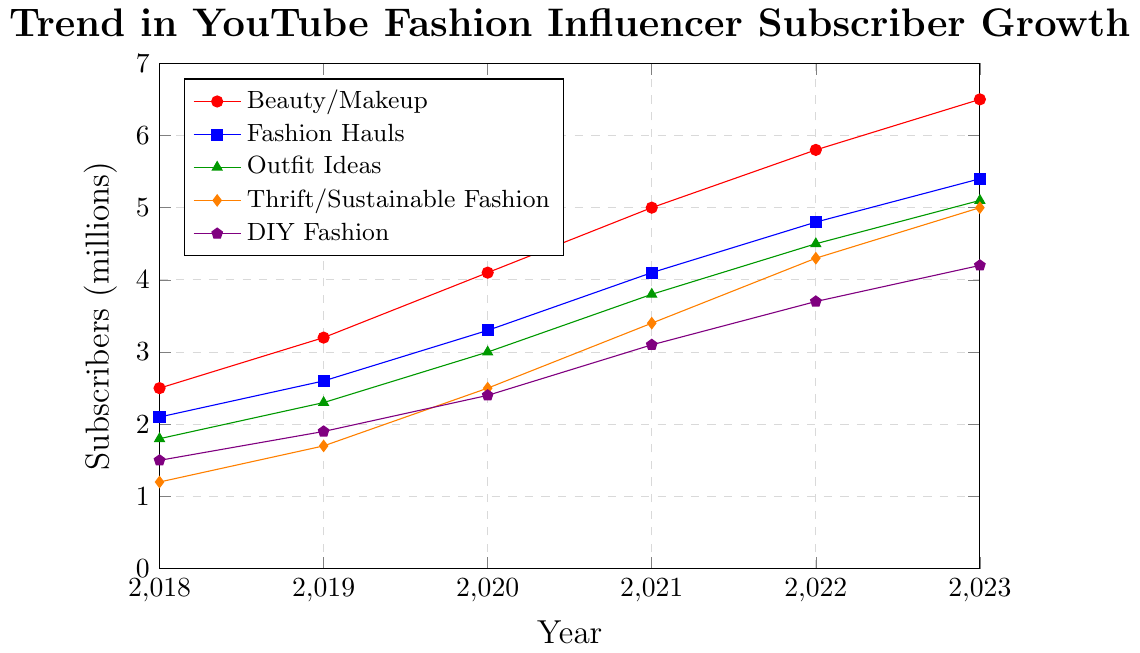What is the trend in subscriber growth for Beauty/Makeup content from 2018 to 2023? The chart shows that the subscriber count for Beauty/Makeup content increased each year from 2.5 million in 2018 to 6.5 million in 2023.
Answer: Consistent increase Which content type had the highest subscriber growth in 2023? By inspecting the chart for the year 2023, Beauty/Makeup reached 6.5 million subscribers, which is the highest among all content types.
Answer: Beauty/Makeup How much did the subscriber count for Thrift/Sustainable Fashion content increase from 2018 to 2023? The Thrift/Sustainable Fashion content rose from 1.2 million subscribers in 2018 to 5.0 million in 2023. The increase is calculated as 5.0 - 1.2 = 3.8 million.
Answer: 3.8 million Was the growth in Fashion Hauls subscribers greater between 2019 and 2020 or between 2022 and 2023? Between 2019 and 2020, the growth for Fashion Hauls is 3.3 - 2.6 = 0.7 million. Between 2022 and 2023, the increase is 5.4 - 4.8 = 0.6 million. Thus, the growth from 2019 to 2020 was greater.
Answer: 2019 to 2020 Which content type had the least growth overall from 2018 to 2023? By comparing the subscriber counts from 2018 to 2023, DIY Fashion increased from 1.5 to 4.2 million, the least among all content types.
Answer: DIY Fashion What was the average number of subscribers for Outfit Ideas in the given period? First, sum the subscriber counts for Outfit Ideas: 1.8 + 2.3 + 3.0 + 3.8 + 4.5 + 5.1 = 20.5 million. There are 6 years, so the average is 20.5 / 6 = 3.417 million.
Answer: 3.417 million By what percentage did Beauty/Makeup subscribers grow from 2020 to 2023? In 2020, there were 4.1 million subscribers, and in 2023, there were 6.5 million. The growth is 6.5 - 4.1 = 2.4 million. The percentage growth is (2.4 / 4.1) * 100 = 58.54%.
Answer: 58.54% Which content type had the fastest annual growth rate between 2020 and 2021? By calculating the differences for each content type between 2020 and 2021:
Beauty/Makeup: 5.0 - 4.1 = 0.9 million
Fashion Hauls: 4.1 - 3.3 = 0.8 million
Outfit Ideas: 3.8 - 3.0 = 0.8 million
Thrift/Sustainable Fashion: 3.4 - 2.5 = 0.9 million
DIY Fashion: 3.1 - 2.4 = 0.7 million
Beauty/Makeup and Thrift/Sustainable Fashion both have the highest growth of 0.9 million.
Answer: Beauty/Makeup and Thrift/Sustainable Fashion Which year saw the largest overall increase in subscribers for the outfit ideas category? By comparing year-to-year increments: 
2018-2019: 2.3 - 1.8 = 0.5 million
2019-2020: 3.0 - 2.3 = 0.7 million 
2020-2021: 3.8 - 3.0 = 0.8 million
2021-2022: 4.5 - 3.8 = 0.7 million
2022-2023: 5.1 - 4.5 = 0.6 million
The largest increase was from 2020 to 2021.
Answer: 2020 to 2021 Which year did Fashion Hauls first exceed 3 million subscribers? By looking at the Fashion Hauls trend, in 2020, the subscriber count was 3.3 million, exceeding 3 million for the first time.
Answer: 2020 